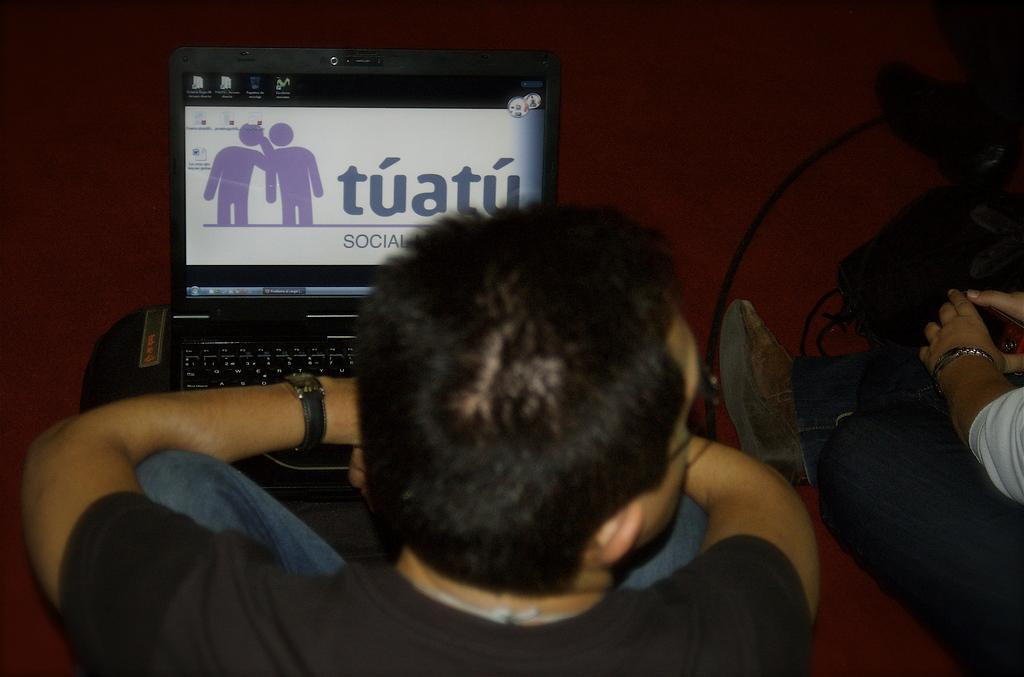<image>
Describe the image concisely. A man's laptop is open to the Tuatu website. 